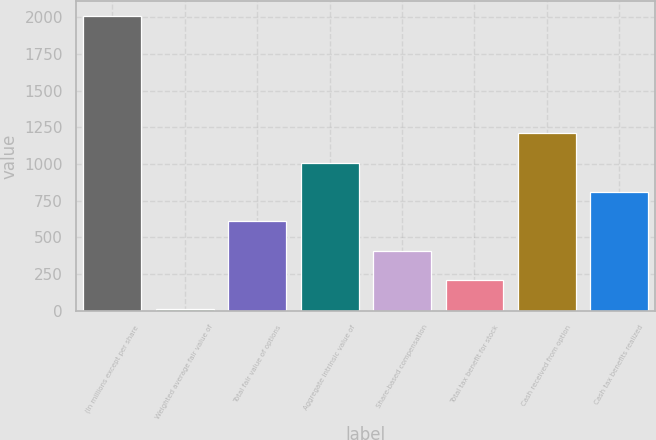<chart> <loc_0><loc_0><loc_500><loc_500><bar_chart><fcel>(In millions except per share<fcel>Weighted average fair value of<fcel>Total fair value of options<fcel>Aggregate intrinsic value of<fcel>Share-based compensation<fcel>Total tax benefit for stock<fcel>Cash received from option<fcel>Cash tax benefits realized<nl><fcel>2011<fcel>10.44<fcel>610.62<fcel>1010.74<fcel>410.56<fcel>210.5<fcel>1210.8<fcel>810.68<nl></chart> 